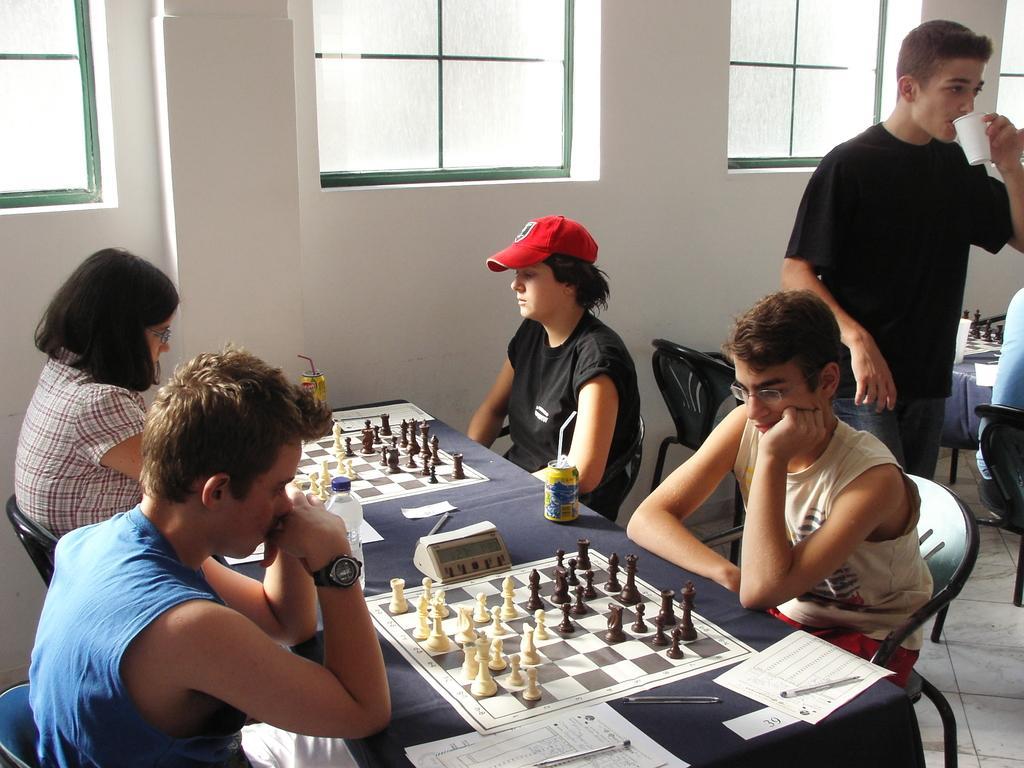How would you summarize this image in a sentence or two? In this picture there are two men and women who are playing chess. There is a chessboard, bottle, cane, straw, paper, pen on the table. There is a man standing and holding a cup. There are few other people playing chess. 